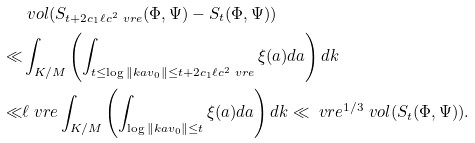Convert formula to latex. <formula><loc_0><loc_0><loc_500><loc_500>& \ v o l ( S _ { t + 2 c _ { 1 } \ell c ^ { 2 } \ v r e } ( \Phi , \Psi ) - S _ { t } ( \Phi , \Psi ) ) \\ \ll & \int _ { K / M } \left ( \int _ { t \leq \log \| k a v _ { 0 } \| \leq t + 2 c _ { 1 } \ell c ^ { 2 } \ v r e } \xi ( a ) d a \right ) d k \\ \ll & \ell \ v r e \int _ { K / M } \left ( \int _ { \log \| k a v _ { 0 } \| \leq t } \xi ( a ) d a \right ) d k \ll \ v r e ^ { 1 / 3 } \ v o l ( S _ { t } ( \Phi , \Psi ) ) .</formula> 